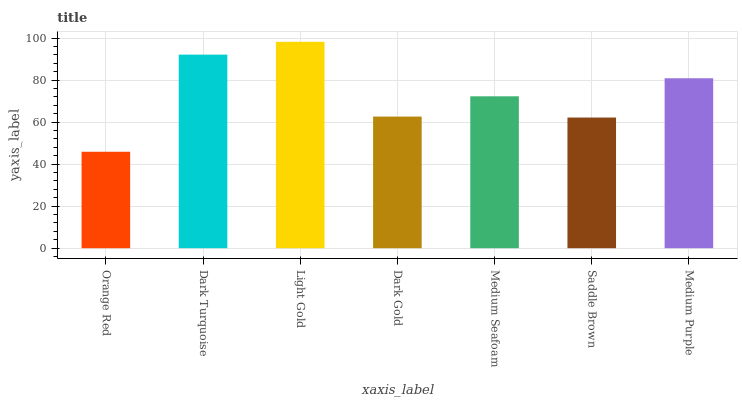Is Orange Red the minimum?
Answer yes or no. Yes. Is Light Gold the maximum?
Answer yes or no. Yes. Is Dark Turquoise the minimum?
Answer yes or no. No. Is Dark Turquoise the maximum?
Answer yes or no. No. Is Dark Turquoise greater than Orange Red?
Answer yes or no. Yes. Is Orange Red less than Dark Turquoise?
Answer yes or no. Yes. Is Orange Red greater than Dark Turquoise?
Answer yes or no. No. Is Dark Turquoise less than Orange Red?
Answer yes or no. No. Is Medium Seafoam the high median?
Answer yes or no. Yes. Is Medium Seafoam the low median?
Answer yes or no. Yes. Is Light Gold the high median?
Answer yes or no. No. Is Dark Turquoise the low median?
Answer yes or no. No. 